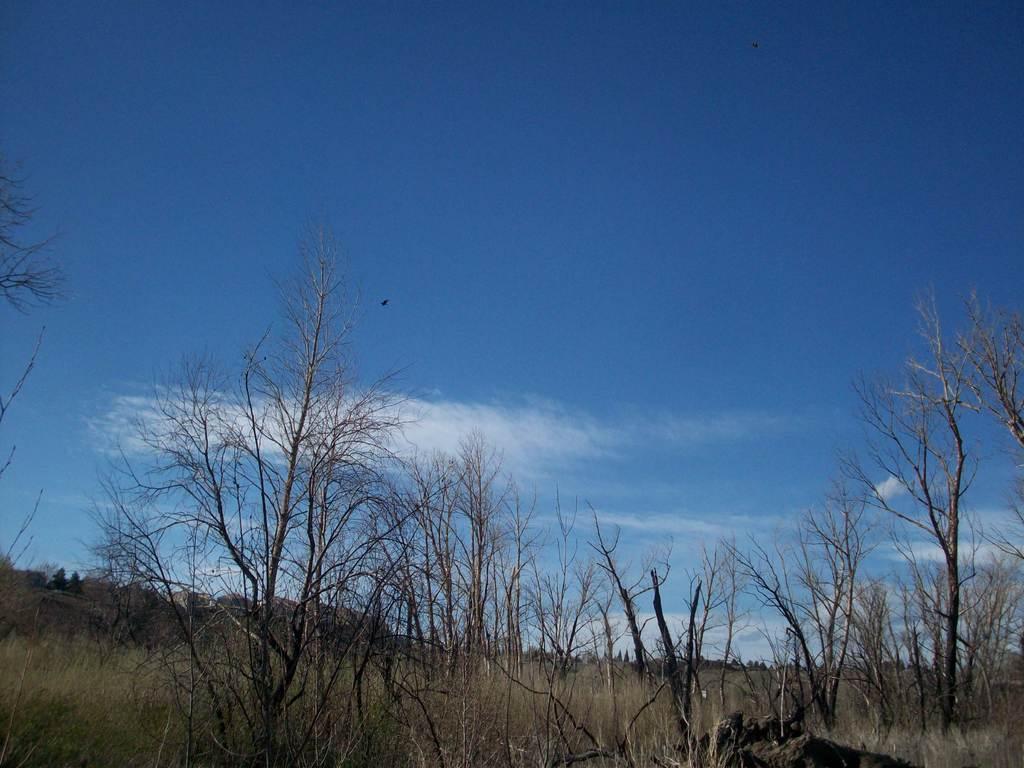Can you describe this image briefly? In this picture I can see number of trees and plants in front. In the background I see the clear sky. 